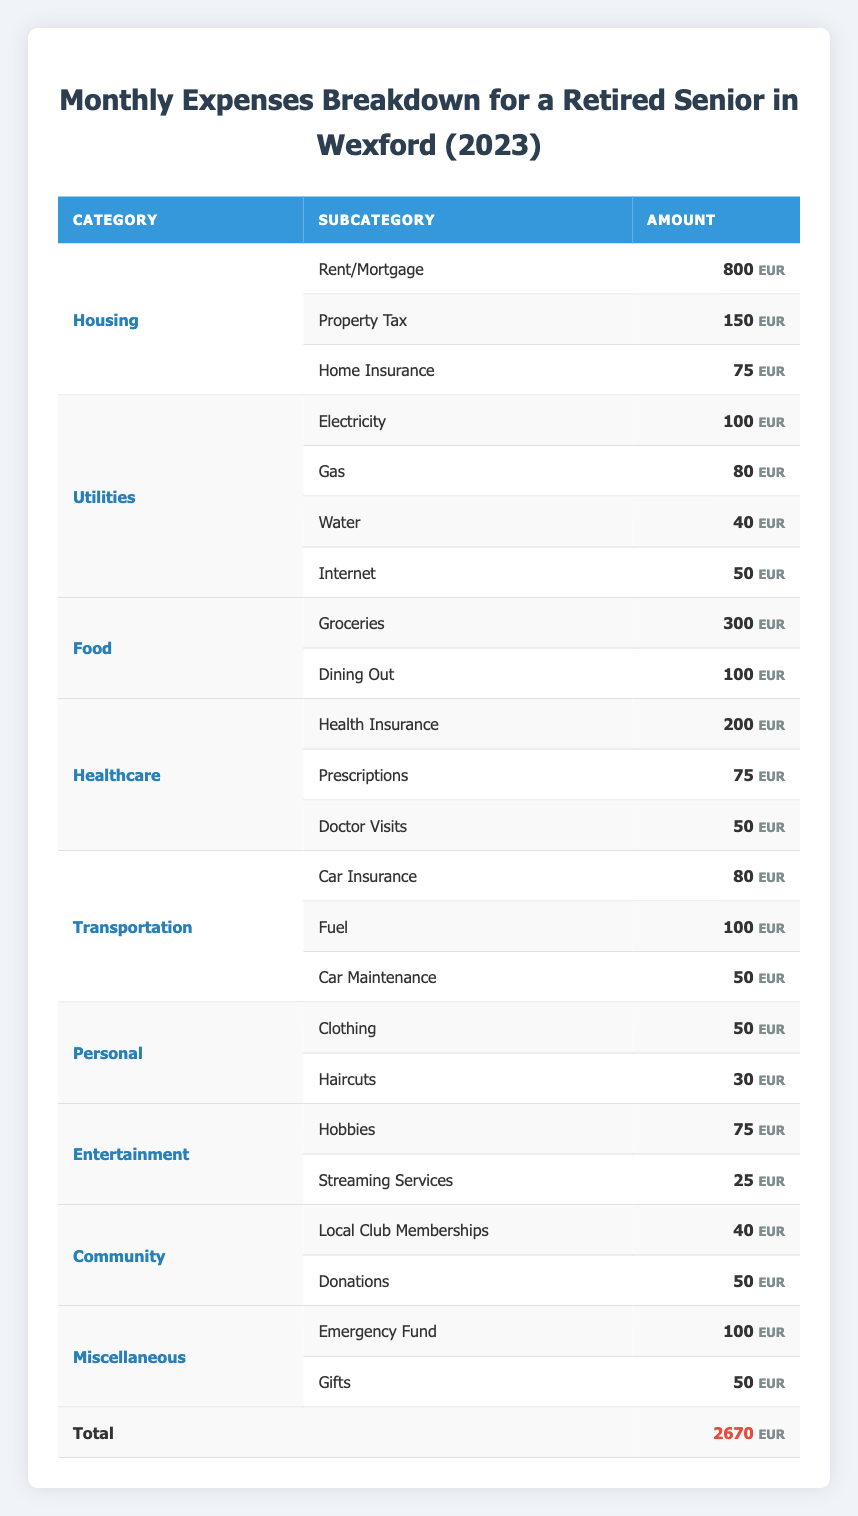What is the total amount spent on Housing? The Housing category has three subcategories: Rent/Mortgage (800), Property Tax (150), and Home Insurance (75). Adding these amounts together: 800 + 150 + 75 equals 1025.
Answer: 1025 What is the amount spent on Food relative to Healthcare? The total amount spent on Food is the sum of Groceries (300) and Dining Out (100), which totals 400. The Healthcare category sums Health Insurance (200), Prescriptions (75), and Doctor Visits (50) for a total of 325. Comparing the two, Food (400) is greater than Healthcare (325).
Answer: Food is greater How much is spent on Entertainment? There are two subcategories under Entertainment: Hobbies (75) and Streaming Services (25). Adding these two gives: 75 + 25 equals 100.
Answer: 100 Is there a category that has a total amount greater than 500? The only category that sums up to more than 500 is Housing, which totals 1025 (as calculated earlier). No other category exceeds that amount.
Answer: Yes, Housing What is the difference in spending between Utilities and Transportation? The total Utilities amount is Electricity (100), Gas (80), Water (40), and Internet (50), which sums to 270. The total for Transportation is Car Insurance (80), Fuel (100), and Car Maintenance (50), summing to 230. The difference is 270 - 230, which equals 40.
Answer: 40 What is the total miscellaneous spending? The Miscellaneous category has Emergency Fund (100) and Gifts (50). Thus, the total is 100 + 50 which equals 150.
Answer: 150 What is the average monthly expense across all categories? The total monthly expenses sum to 2670, and there are 15 subcategories. To find the average, we divide 2670 by 15, which equals 178.
Answer: 178 Are there any categories with a spending less than 100? Looking at the categories, Personal with Clothing (50) and Haircuts (30), Entertainment with Streaming Services (25), Community with Local Club Memberships (40), Donations (50), and Miscellaneous with Gifts (50) all have individual subcategories under 100.
Answer: Yes, there are several What percentage of the total expenses is spent on Healthcare? The total for Healthcare is Health Insurance (200), Prescriptions (75), and Doctor Visits (50), which totals 325. To find the percentage, we use the formula (325 / 2670) * 100, giving approximately 12.17%.
Answer: 12.17% 